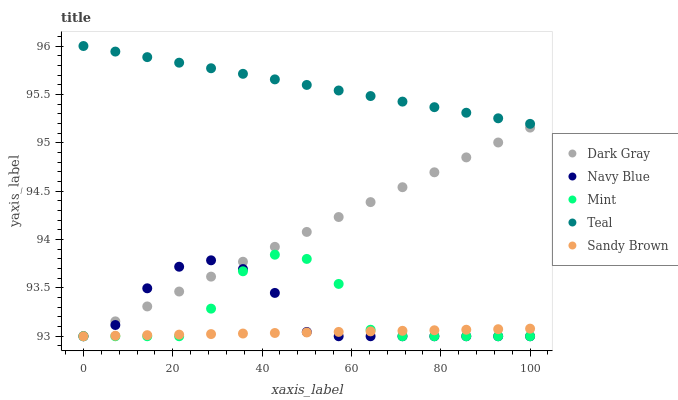Does Sandy Brown have the minimum area under the curve?
Answer yes or no. Yes. Does Teal have the maximum area under the curve?
Answer yes or no. Yes. Does Navy Blue have the minimum area under the curve?
Answer yes or no. No. Does Navy Blue have the maximum area under the curve?
Answer yes or no. No. Is Dark Gray the smoothest?
Answer yes or no. Yes. Is Mint the roughest?
Answer yes or no. Yes. Is Navy Blue the smoothest?
Answer yes or no. No. Is Navy Blue the roughest?
Answer yes or no. No. Does Dark Gray have the lowest value?
Answer yes or no. Yes. Does Teal have the lowest value?
Answer yes or no. No. Does Teal have the highest value?
Answer yes or no. Yes. Does Navy Blue have the highest value?
Answer yes or no. No. Is Mint less than Teal?
Answer yes or no. Yes. Is Teal greater than Sandy Brown?
Answer yes or no. Yes. Does Mint intersect Navy Blue?
Answer yes or no. Yes. Is Mint less than Navy Blue?
Answer yes or no. No. Is Mint greater than Navy Blue?
Answer yes or no. No. Does Mint intersect Teal?
Answer yes or no. No. 